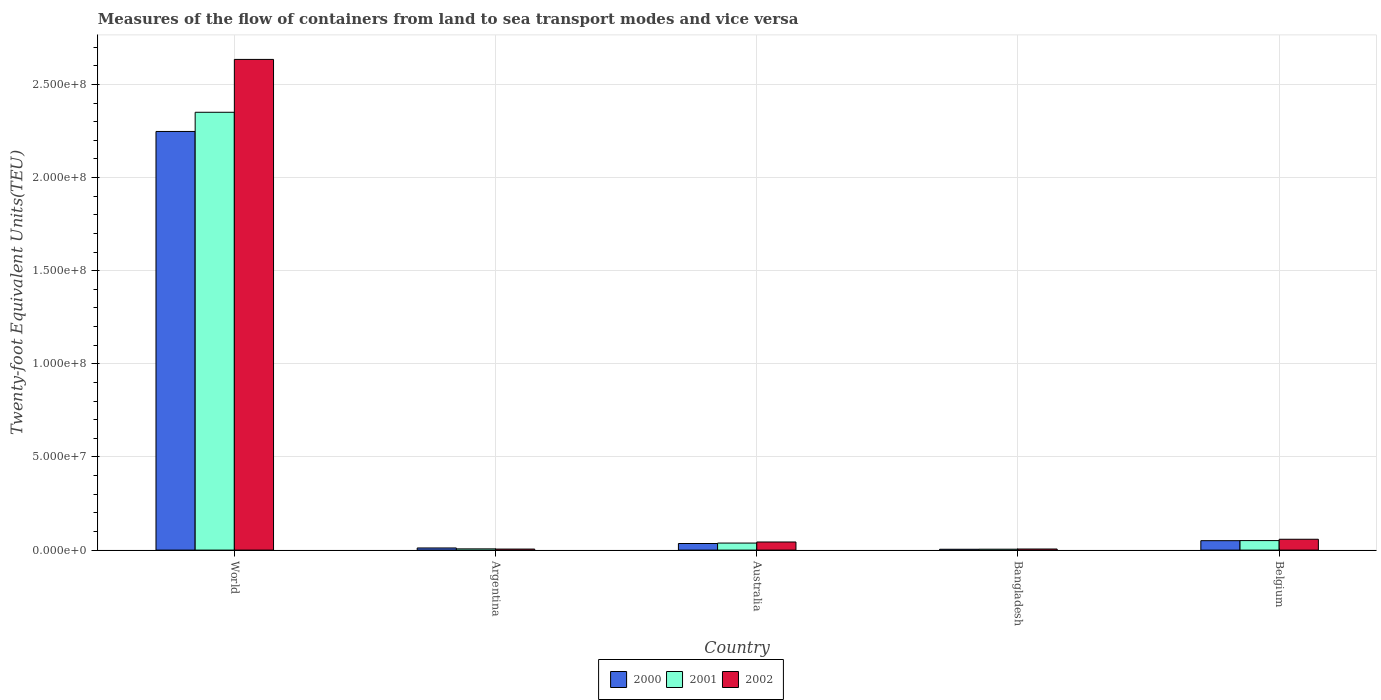How many different coloured bars are there?
Offer a very short reply. 3. How many groups of bars are there?
Your answer should be very brief. 5. Are the number of bars per tick equal to the number of legend labels?
Provide a short and direct response. Yes. How many bars are there on the 4th tick from the left?
Make the answer very short. 3. What is the label of the 1st group of bars from the left?
Provide a short and direct response. World. What is the container port traffic in 2002 in Bangladesh?
Your answer should be compact. 5.84e+05. Across all countries, what is the maximum container port traffic in 2002?
Offer a terse response. 2.63e+08. Across all countries, what is the minimum container port traffic in 2002?
Your answer should be compact. 5.55e+05. In which country was the container port traffic in 2001 minimum?
Provide a succinct answer. Bangladesh. What is the total container port traffic in 2000 in the graph?
Your answer should be very brief. 2.35e+08. What is the difference between the container port traffic in 2000 in Bangladesh and that in Belgium?
Make the answer very short. -4.60e+06. What is the difference between the container port traffic in 2001 in Bangladesh and the container port traffic in 2002 in Australia?
Provide a short and direct response. -3.87e+06. What is the average container port traffic in 2000 per country?
Your answer should be compact. 4.70e+07. What is the difference between the container port traffic of/in 2000 and container port traffic of/in 2001 in Bangladesh?
Provide a short and direct response. -3.03e+04. In how many countries, is the container port traffic in 2002 greater than 190000000 TEU?
Give a very brief answer. 1. What is the ratio of the container port traffic in 2001 in Argentina to that in World?
Give a very brief answer. 0. Is the container port traffic in 2002 in Bangladesh less than that in Belgium?
Your answer should be compact. Yes. Is the difference between the container port traffic in 2000 in Argentina and Australia greater than the difference between the container port traffic in 2001 in Argentina and Australia?
Make the answer very short. Yes. What is the difference between the highest and the second highest container port traffic in 2002?
Your answer should be very brief. 1.47e+06. What is the difference between the highest and the lowest container port traffic in 2001?
Keep it short and to the point. 2.35e+08. Is the sum of the container port traffic in 2002 in Argentina and Bangladesh greater than the maximum container port traffic in 2000 across all countries?
Ensure brevity in your answer.  No. What does the 3rd bar from the right in Australia represents?
Offer a very short reply. 2000. How many bars are there?
Offer a terse response. 15. Are all the bars in the graph horizontal?
Your answer should be compact. No. Are the values on the major ticks of Y-axis written in scientific E-notation?
Your answer should be compact. Yes. Where does the legend appear in the graph?
Make the answer very short. Bottom center. What is the title of the graph?
Your answer should be compact. Measures of the flow of containers from land to sea transport modes and vice versa. Does "1965" appear as one of the legend labels in the graph?
Keep it short and to the point. No. What is the label or title of the Y-axis?
Keep it short and to the point. Twenty-foot Equivalent Units(TEU). What is the Twenty-foot Equivalent Units(TEU) in 2000 in World?
Provide a short and direct response. 2.25e+08. What is the Twenty-foot Equivalent Units(TEU) in 2001 in World?
Make the answer very short. 2.35e+08. What is the Twenty-foot Equivalent Units(TEU) in 2002 in World?
Offer a very short reply. 2.63e+08. What is the Twenty-foot Equivalent Units(TEU) in 2000 in Argentina?
Keep it short and to the point. 1.14e+06. What is the Twenty-foot Equivalent Units(TEU) in 2001 in Argentina?
Provide a short and direct response. 6.64e+05. What is the Twenty-foot Equivalent Units(TEU) in 2002 in Argentina?
Your answer should be very brief. 5.55e+05. What is the Twenty-foot Equivalent Units(TEU) in 2000 in Australia?
Give a very brief answer. 3.54e+06. What is the Twenty-foot Equivalent Units(TEU) of 2001 in Australia?
Provide a succinct answer. 3.77e+06. What is the Twenty-foot Equivalent Units(TEU) of 2002 in Australia?
Offer a terse response. 4.36e+06. What is the Twenty-foot Equivalent Units(TEU) of 2000 in Bangladesh?
Your response must be concise. 4.56e+05. What is the Twenty-foot Equivalent Units(TEU) of 2001 in Bangladesh?
Make the answer very short. 4.86e+05. What is the Twenty-foot Equivalent Units(TEU) in 2002 in Bangladesh?
Offer a very short reply. 5.84e+05. What is the Twenty-foot Equivalent Units(TEU) in 2000 in Belgium?
Your response must be concise. 5.06e+06. What is the Twenty-foot Equivalent Units(TEU) of 2001 in Belgium?
Make the answer very short. 5.11e+06. What is the Twenty-foot Equivalent Units(TEU) of 2002 in Belgium?
Your response must be concise. 5.83e+06. Across all countries, what is the maximum Twenty-foot Equivalent Units(TEU) of 2000?
Give a very brief answer. 2.25e+08. Across all countries, what is the maximum Twenty-foot Equivalent Units(TEU) of 2001?
Offer a terse response. 2.35e+08. Across all countries, what is the maximum Twenty-foot Equivalent Units(TEU) in 2002?
Your answer should be very brief. 2.63e+08. Across all countries, what is the minimum Twenty-foot Equivalent Units(TEU) in 2000?
Provide a succinct answer. 4.56e+05. Across all countries, what is the minimum Twenty-foot Equivalent Units(TEU) of 2001?
Provide a succinct answer. 4.86e+05. Across all countries, what is the minimum Twenty-foot Equivalent Units(TEU) of 2002?
Offer a terse response. 5.55e+05. What is the total Twenty-foot Equivalent Units(TEU) of 2000 in the graph?
Your answer should be very brief. 2.35e+08. What is the total Twenty-foot Equivalent Units(TEU) in 2001 in the graph?
Offer a terse response. 2.45e+08. What is the total Twenty-foot Equivalent Units(TEU) of 2002 in the graph?
Ensure brevity in your answer.  2.75e+08. What is the difference between the Twenty-foot Equivalent Units(TEU) of 2000 in World and that in Argentina?
Your answer should be very brief. 2.24e+08. What is the difference between the Twenty-foot Equivalent Units(TEU) of 2001 in World and that in Argentina?
Keep it short and to the point. 2.34e+08. What is the difference between the Twenty-foot Equivalent Units(TEU) of 2002 in World and that in Argentina?
Your response must be concise. 2.63e+08. What is the difference between the Twenty-foot Equivalent Units(TEU) in 2000 in World and that in Australia?
Your response must be concise. 2.21e+08. What is the difference between the Twenty-foot Equivalent Units(TEU) in 2001 in World and that in Australia?
Offer a terse response. 2.31e+08. What is the difference between the Twenty-foot Equivalent Units(TEU) in 2002 in World and that in Australia?
Your response must be concise. 2.59e+08. What is the difference between the Twenty-foot Equivalent Units(TEU) of 2000 in World and that in Bangladesh?
Keep it short and to the point. 2.24e+08. What is the difference between the Twenty-foot Equivalent Units(TEU) in 2001 in World and that in Bangladesh?
Provide a succinct answer. 2.35e+08. What is the difference between the Twenty-foot Equivalent Units(TEU) of 2002 in World and that in Bangladesh?
Your response must be concise. 2.63e+08. What is the difference between the Twenty-foot Equivalent Units(TEU) in 2000 in World and that in Belgium?
Provide a succinct answer. 2.20e+08. What is the difference between the Twenty-foot Equivalent Units(TEU) of 2001 in World and that in Belgium?
Keep it short and to the point. 2.30e+08. What is the difference between the Twenty-foot Equivalent Units(TEU) in 2002 in World and that in Belgium?
Your response must be concise. 2.58e+08. What is the difference between the Twenty-foot Equivalent Units(TEU) of 2000 in Argentina and that in Australia?
Give a very brief answer. -2.40e+06. What is the difference between the Twenty-foot Equivalent Units(TEU) in 2001 in Argentina and that in Australia?
Make the answer very short. -3.11e+06. What is the difference between the Twenty-foot Equivalent Units(TEU) of 2002 in Argentina and that in Australia?
Provide a short and direct response. -3.80e+06. What is the difference between the Twenty-foot Equivalent Units(TEU) of 2000 in Argentina and that in Bangladesh?
Offer a very short reply. 6.89e+05. What is the difference between the Twenty-foot Equivalent Units(TEU) of 2001 in Argentina and that in Bangladesh?
Give a very brief answer. 1.78e+05. What is the difference between the Twenty-foot Equivalent Units(TEU) in 2002 in Argentina and that in Bangladesh?
Make the answer very short. -2.94e+04. What is the difference between the Twenty-foot Equivalent Units(TEU) of 2000 in Argentina and that in Belgium?
Your answer should be very brief. -3.91e+06. What is the difference between the Twenty-foot Equivalent Units(TEU) in 2001 in Argentina and that in Belgium?
Ensure brevity in your answer.  -4.45e+06. What is the difference between the Twenty-foot Equivalent Units(TEU) in 2002 in Argentina and that in Belgium?
Your response must be concise. -5.27e+06. What is the difference between the Twenty-foot Equivalent Units(TEU) of 2000 in Australia and that in Bangladesh?
Your response must be concise. 3.09e+06. What is the difference between the Twenty-foot Equivalent Units(TEU) in 2001 in Australia and that in Bangladesh?
Your response must be concise. 3.29e+06. What is the difference between the Twenty-foot Equivalent Units(TEU) of 2002 in Australia and that in Bangladesh?
Ensure brevity in your answer.  3.77e+06. What is the difference between the Twenty-foot Equivalent Units(TEU) in 2000 in Australia and that in Belgium?
Provide a short and direct response. -1.51e+06. What is the difference between the Twenty-foot Equivalent Units(TEU) in 2001 in Australia and that in Belgium?
Provide a short and direct response. -1.33e+06. What is the difference between the Twenty-foot Equivalent Units(TEU) of 2002 in Australia and that in Belgium?
Provide a short and direct response. -1.47e+06. What is the difference between the Twenty-foot Equivalent Units(TEU) of 2000 in Bangladesh and that in Belgium?
Keep it short and to the point. -4.60e+06. What is the difference between the Twenty-foot Equivalent Units(TEU) of 2001 in Bangladesh and that in Belgium?
Your response must be concise. -4.62e+06. What is the difference between the Twenty-foot Equivalent Units(TEU) of 2002 in Bangladesh and that in Belgium?
Ensure brevity in your answer.  -5.24e+06. What is the difference between the Twenty-foot Equivalent Units(TEU) in 2000 in World and the Twenty-foot Equivalent Units(TEU) in 2001 in Argentina?
Keep it short and to the point. 2.24e+08. What is the difference between the Twenty-foot Equivalent Units(TEU) in 2000 in World and the Twenty-foot Equivalent Units(TEU) in 2002 in Argentina?
Provide a short and direct response. 2.24e+08. What is the difference between the Twenty-foot Equivalent Units(TEU) in 2001 in World and the Twenty-foot Equivalent Units(TEU) in 2002 in Argentina?
Offer a very short reply. 2.35e+08. What is the difference between the Twenty-foot Equivalent Units(TEU) of 2000 in World and the Twenty-foot Equivalent Units(TEU) of 2001 in Australia?
Provide a succinct answer. 2.21e+08. What is the difference between the Twenty-foot Equivalent Units(TEU) in 2000 in World and the Twenty-foot Equivalent Units(TEU) in 2002 in Australia?
Your answer should be compact. 2.20e+08. What is the difference between the Twenty-foot Equivalent Units(TEU) of 2001 in World and the Twenty-foot Equivalent Units(TEU) of 2002 in Australia?
Give a very brief answer. 2.31e+08. What is the difference between the Twenty-foot Equivalent Units(TEU) of 2000 in World and the Twenty-foot Equivalent Units(TEU) of 2001 in Bangladesh?
Your answer should be very brief. 2.24e+08. What is the difference between the Twenty-foot Equivalent Units(TEU) in 2000 in World and the Twenty-foot Equivalent Units(TEU) in 2002 in Bangladesh?
Make the answer very short. 2.24e+08. What is the difference between the Twenty-foot Equivalent Units(TEU) of 2001 in World and the Twenty-foot Equivalent Units(TEU) of 2002 in Bangladesh?
Keep it short and to the point. 2.34e+08. What is the difference between the Twenty-foot Equivalent Units(TEU) in 2000 in World and the Twenty-foot Equivalent Units(TEU) in 2001 in Belgium?
Ensure brevity in your answer.  2.20e+08. What is the difference between the Twenty-foot Equivalent Units(TEU) in 2000 in World and the Twenty-foot Equivalent Units(TEU) in 2002 in Belgium?
Give a very brief answer. 2.19e+08. What is the difference between the Twenty-foot Equivalent Units(TEU) in 2001 in World and the Twenty-foot Equivalent Units(TEU) in 2002 in Belgium?
Keep it short and to the point. 2.29e+08. What is the difference between the Twenty-foot Equivalent Units(TEU) of 2000 in Argentina and the Twenty-foot Equivalent Units(TEU) of 2001 in Australia?
Give a very brief answer. -2.63e+06. What is the difference between the Twenty-foot Equivalent Units(TEU) in 2000 in Argentina and the Twenty-foot Equivalent Units(TEU) in 2002 in Australia?
Your response must be concise. -3.21e+06. What is the difference between the Twenty-foot Equivalent Units(TEU) of 2001 in Argentina and the Twenty-foot Equivalent Units(TEU) of 2002 in Australia?
Offer a terse response. -3.69e+06. What is the difference between the Twenty-foot Equivalent Units(TEU) in 2000 in Argentina and the Twenty-foot Equivalent Units(TEU) in 2001 in Bangladesh?
Your answer should be compact. 6.59e+05. What is the difference between the Twenty-foot Equivalent Units(TEU) of 2000 in Argentina and the Twenty-foot Equivalent Units(TEU) of 2002 in Bangladesh?
Give a very brief answer. 5.61e+05. What is the difference between the Twenty-foot Equivalent Units(TEU) of 2001 in Argentina and the Twenty-foot Equivalent Units(TEU) of 2002 in Bangladesh?
Your answer should be compact. 7.96e+04. What is the difference between the Twenty-foot Equivalent Units(TEU) in 2000 in Argentina and the Twenty-foot Equivalent Units(TEU) in 2001 in Belgium?
Your response must be concise. -3.96e+06. What is the difference between the Twenty-foot Equivalent Units(TEU) of 2000 in Argentina and the Twenty-foot Equivalent Units(TEU) of 2002 in Belgium?
Offer a very short reply. -4.68e+06. What is the difference between the Twenty-foot Equivalent Units(TEU) of 2001 in Argentina and the Twenty-foot Equivalent Units(TEU) of 2002 in Belgium?
Your answer should be very brief. -5.16e+06. What is the difference between the Twenty-foot Equivalent Units(TEU) of 2000 in Australia and the Twenty-foot Equivalent Units(TEU) of 2001 in Bangladesh?
Provide a short and direct response. 3.06e+06. What is the difference between the Twenty-foot Equivalent Units(TEU) in 2000 in Australia and the Twenty-foot Equivalent Units(TEU) in 2002 in Bangladesh?
Your answer should be very brief. 2.96e+06. What is the difference between the Twenty-foot Equivalent Units(TEU) in 2001 in Australia and the Twenty-foot Equivalent Units(TEU) in 2002 in Bangladesh?
Give a very brief answer. 3.19e+06. What is the difference between the Twenty-foot Equivalent Units(TEU) of 2000 in Australia and the Twenty-foot Equivalent Units(TEU) of 2001 in Belgium?
Ensure brevity in your answer.  -1.57e+06. What is the difference between the Twenty-foot Equivalent Units(TEU) in 2000 in Australia and the Twenty-foot Equivalent Units(TEU) in 2002 in Belgium?
Your response must be concise. -2.28e+06. What is the difference between the Twenty-foot Equivalent Units(TEU) of 2001 in Australia and the Twenty-foot Equivalent Units(TEU) of 2002 in Belgium?
Ensure brevity in your answer.  -2.05e+06. What is the difference between the Twenty-foot Equivalent Units(TEU) in 2000 in Bangladesh and the Twenty-foot Equivalent Units(TEU) in 2001 in Belgium?
Your answer should be compact. -4.65e+06. What is the difference between the Twenty-foot Equivalent Units(TEU) of 2000 in Bangladesh and the Twenty-foot Equivalent Units(TEU) of 2002 in Belgium?
Provide a succinct answer. -5.37e+06. What is the difference between the Twenty-foot Equivalent Units(TEU) in 2001 in Bangladesh and the Twenty-foot Equivalent Units(TEU) in 2002 in Belgium?
Your answer should be very brief. -5.34e+06. What is the average Twenty-foot Equivalent Units(TEU) in 2000 per country?
Offer a very short reply. 4.70e+07. What is the average Twenty-foot Equivalent Units(TEU) of 2001 per country?
Give a very brief answer. 4.90e+07. What is the average Twenty-foot Equivalent Units(TEU) in 2002 per country?
Your answer should be very brief. 5.50e+07. What is the difference between the Twenty-foot Equivalent Units(TEU) of 2000 and Twenty-foot Equivalent Units(TEU) of 2001 in World?
Keep it short and to the point. -1.03e+07. What is the difference between the Twenty-foot Equivalent Units(TEU) of 2000 and Twenty-foot Equivalent Units(TEU) of 2002 in World?
Provide a succinct answer. -3.87e+07. What is the difference between the Twenty-foot Equivalent Units(TEU) of 2001 and Twenty-foot Equivalent Units(TEU) of 2002 in World?
Keep it short and to the point. -2.84e+07. What is the difference between the Twenty-foot Equivalent Units(TEU) of 2000 and Twenty-foot Equivalent Units(TEU) of 2001 in Argentina?
Keep it short and to the point. 4.81e+05. What is the difference between the Twenty-foot Equivalent Units(TEU) in 2000 and Twenty-foot Equivalent Units(TEU) in 2002 in Argentina?
Give a very brief answer. 5.90e+05. What is the difference between the Twenty-foot Equivalent Units(TEU) in 2001 and Twenty-foot Equivalent Units(TEU) in 2002 in Argentina?
Your answer should be very brief. 1.09e+05. What is the difference between the Twenty-foot Equivalent Units(TEU) in 2000 and Twenty-foot Equivalent Units(TEU) in 2001 in Australia?
Your answer should be very brief. -2.32e+05. What is the difference between the Twenty-foot Equivalent Units(TEU) of 2000 and Twenty-foot Equivalent Units(TEU) of 2002 in Australia?
Your answer should be compact. -8.12e+05. What is the difference between the Twenty-foot Equivalent Units(TEU) of 2001 and Twenty-foot Equivalent Units(TEU) of 2002 in Australia?
Keep it short and to the point. -5.80e+05. What is the difference between the Twenty-foot Equivalent Units(TEU) of 2000 and Twenty-foot Equivalent Units(TEU) of 2001 in Bangladesh?
Ensure brevity in your answer.  -3.03e+04. What is the difference between the Twenty-foot Equivalent Units(TEU) of 2000 and Twenty-foot Equivalent Units(TEU) of 2002 in Bangladesh?
Keep it short and to the point. -1.28e+05. What is the difference between the Twenty-foot Equivalent Units(TEU) in 2001 and Twenty-foot Equivalent Units(TEU) in 2002 in Bangladesh?
Ensure brevity in your answer.  -9.79e+04. What is the difference between the Twenty-foot Equivalent Units(TEU) of 2000 and Twenty-foot Equivalent Units(TEU) of 2001 in Belgium?
Your answer should be compact. -5.21e+04. What is the difference between the Twenty-foot Equivalent Units(TEU) of 2000 and Twenty-foot Equivalent Units(TEU) of 2002 in Belgium?
Your answer should be compact. -7.68e+05. What is the difference between the Twenty-foot Equivalent Units(TEU) of 2001 and Twenty-foot Equivalent Units(TEU) of 2002 in Belgium?
Your response must be concise. -7.16e+05. What is the ratio of the Twenty-foot Equivalent Units(TEU) in 2000 in World to that in Argentina?
Make the answer very short. 196.34. What is the ratio of the Twenty-foot Equivalent Units(TEU) in 2001 in World to that in Argentina?
Give a very brief answer. 354.13. What is the ratio of the Twenty-foot Equivalent Units(TEU) in 2002 in World to that in Argentina?
Keep it short and to the point. 474.87. What is the ratio of the Twenty-foot Equivalent Units(TEU) in 2000 in World to that in Australia?
Ensure brevity in your answer.  63.45. What is the ratio of the Twenty-foot Equivalent Units(TEU) in 2001 in World to that in Australia?
Offer a very short reply. 62.27. What is the ratio of the Twenty-foot Equivalent Units(TEU) in 2002 in World to that in Australia?
Provide a short and direct response. 60.49. What is the ratio of the Twenty-foot Equivalent Units(TEU) in 2000 in World to that in Bangladesh?
Ensure brevity in your answer.  492.92. What is the ratio of the Twenty-foot Equivalent Units(TEU) in 2001 in World to that in Bangladesh?
Your answer should be compact. 483.41. What is the ratio of the Twenty-foot Equivalent Units(TEU) of 2002 in World to that in Bangladesh?
Provide a short and direct response. 450.95. What is the ratio of the Twenty-foot Equivalent Units(TEU) in 2000 in World to that in Belgium?
Give a very brief answer. 44.44. What is the ratio of the Twenty-foot Equivalent Units(TEU) of 2001 in World to that in Belgium?
Offer a very short reply. 46.01. What is the ratio of the Twenty-foot Equivalent Units(TEU) in 2002 in World to that in Belgium?
Your response must be concise. 45.22. What is the ratio of the Twenty-foot Equivalent Units(TEU) of 2000 in Argentina to that in Australia?
Provide a succinct answer. 0.32. What is the ratio of the Twenty-foot Equivalent Units(TEU) in 2001 in Argentina to that in Australia?
Ensure brevity in your answer.  0.18. What is the ratio of the Twenty-foot Equivalent Units(TEU) in 2002 in Argentina to that in Australia?
Provide a succinct answer. 0.13. What is the ratio of the Twenty-foot Equivalent Units(TEU) in 2000 in Argentina to that in Bangladesh?
Your response must be concise. 2.51. What is the ratio of the Twenty-foot Equivalent Units(TEU) of 2001 in Argentina to that in Bangladesh?
Ensure brevity in your answer.  1.37. What is the ratio of the Twenty-foot Equivalent Units(TEU) in 2002 in Argentina to that in Bangladesh?
Provide a succinct answer. 0.95. What is the ratio of the Twenty-foot Equivalent Units(TEU) in 2000 in Argentina to that in Belgium?
Offer a terse response. 0.23. What is the ratio of the Twenty-foot Equivalent Units(TEU) of 2001 in Argentina to that in Belgium?
Your answer should be compact. 0.13. What is the ratio of the Twenty-foot Equivalent Units(TEU) of 2002 in Argentina to that in Belgium?
Make the answer very short. 0.1. What is the ratio of the Twenty-foot Equivalent Units(TEU) of 2000 in Australia to that in Bangladesh?
Give a very brief answer. 7.77. What is the ratio of the Twenty-foot Equivalent Units(TEU) of 2001 in Australia to that in Bangladesh?
Ensure brevity in your answer.  7.76. What is the ratio of the Twenty-foot Equivalent Units(TEU) of 2002 in Australia to that in Bangladesh?
Offer a very short reply. 7.45. What is the ratio of the Twenty-foot Equivalent Units(TEU) in 2000 in Australia to that in Belgium?
Your answer should be compact. 0.7. What is the ratio of the Twenty-foot Equivalent Units(TEU) of 2001 in Australia to that in Belgium?
Offer a very short reply. 0.74. What is the ratio of the Twenty-foot Equivalent Units(TEU) in 2002 in Australia to that in Belgium?
Make the answer very short. 0.75. What is the ratio of the Twenty-foot Equivalent Units(TEU) of 2000 in Bangladesh to that in Belgium?
Provide a short and direct response. 0.09. What is the ratio of the Twenty-foot Equivalent Units(TEU) of 2001 in Bangladesh to that in Belgium?
Provide a short and direct response. 0.1. What is the ratio of the Twenty-foot Equivalent Units(TEU) in 2002 in Bangladesh to that in Belgium?
Your response must be concise. 0.1. What is the difference between the highest and the second highest Twenty-foot Equivalent Units(TEU) of 2000?
Your response must be concise. 2.20e+08. What is the difference between the highest and the second highest Twenty-foot Equivalent Units(TEU) in 2001?
Your response must be concise. 2.30e+08. What is the difference between the highest and the second highest Twenty-foot Equivalent Units(TEU) in 2002?
Make the answer very short. 2.58e+08. What is the difference between the highest and the lowest Twenty-foot Equivalent Units(TEU) in 2000?
Your answer should be very brief. 2.24e+08. What is the difference between the highest and the lowest Twenty-foot Equivalent Units(TEU) in 2001?
Your answer should be very brief. 2.35e+08. What is the difference between the highest and the lowest Twenty-foot Equivalent Units(TEU) in 2002?
Offer a very short reply. 2.63e+08. 